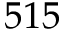<formula> <loc_0><loc_0><loc_500><loc_500>5 1 5</formula> 